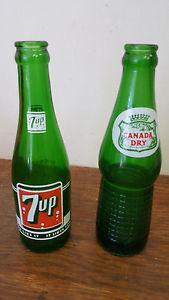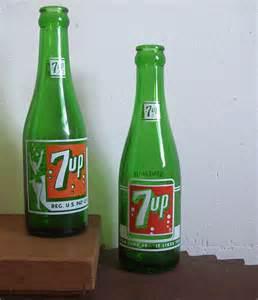The first image is the image on the left, the second image is the image on the right. For the images shown, is this caption "The right image contains two matching green bottles with the same labels, and no image contains cans." true? Answer yes or no. Yes. 